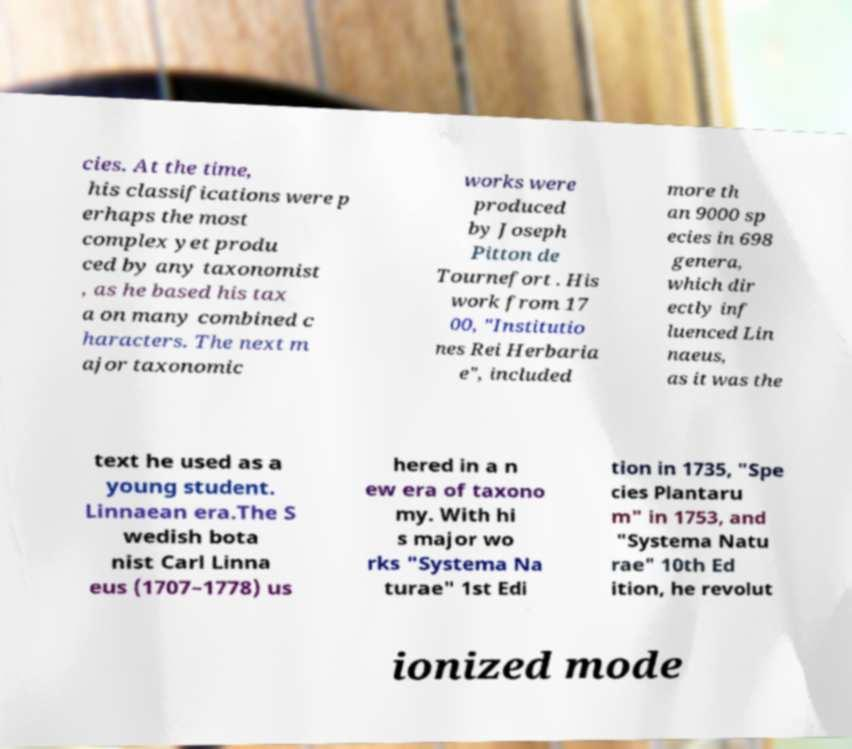Could you assist in decoding the text presented in this image and type it out clearly? cies. At the time, his classifications were p erhaps the most complex yet produ ced by any taxonomist , as he based his tax a on many combined c haracters. The next m ajor taxonomic works were produced by Joseph Pitton de Tournefort . His work from 17 00, "Institutio nes Rei Herbaria e", included more th an 9000 sp ecies in 698 genera, which dir ectly inf luenced Lin naeus, as it was the text he used as a young student. Linnaean era.The S wedish bota nist Carl Linna eus (1707–1778) us hered in a n ew era of taxono my. With hi s major wo rks "Systema Na turae" 1st Edi tion in 1735, "Spe cies Plantaru m" in 1753, and "Systema Natu rae" 10th Ed ition, he revolut ionized mode 